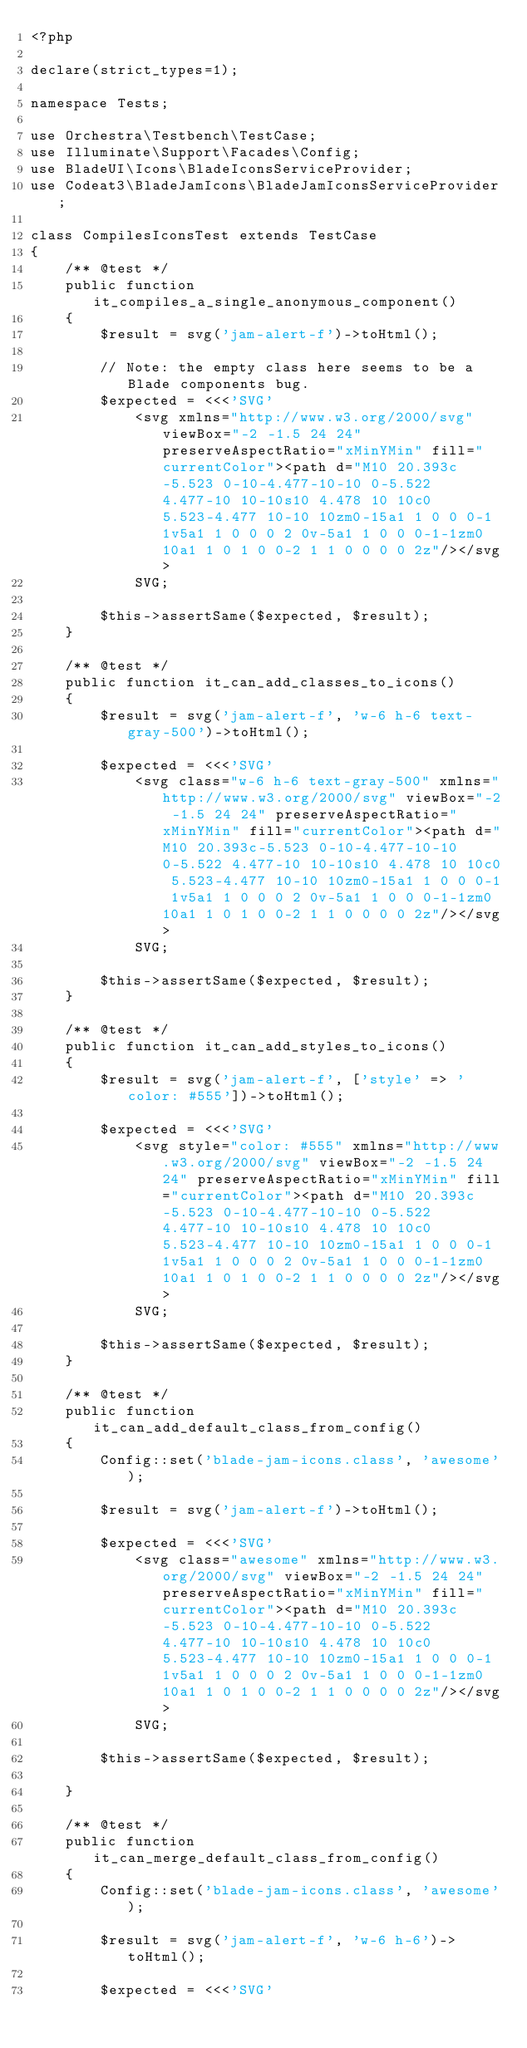<code> <loc_0><loc_0><loc_500><loc_500><_PHP_><?php

declare(strict_types=1);

namespace Tests;

use Orchestra\Testbench\TestCase;
use Illuminate\Support\Facades\Config;
use BladeUI\Icons\BladeIconsServiceProvider;
use Codeat3\BladeJamIcons\BladeJamIconsServiceProvider;

class CompilesIconsTest extends TestCase
{
    /** @test */
    public function it_compiles_a_single_anonymous_component()
    {
        $result = svg('jam-alert-f')->toHtml();

        // Note: the empty class here seems to be a Blade components bug.
        $expected = <<<'SVG'
            <svg xmlns="http://www.w3.org/2000/svg" viewBox="-2 -1.5 24 24" preserveAspectRatio="xMinYMin" fill="currentColor"><path d="M10 20.393c-5.523 0-10-4.477-10-10 0-5.522 4.477-10 10-10s10 4.478 10 10c0 5.523-4.477 10-10 10zm0-15a1 1 0 0 0-1 1v5a1 1 0 0 0 2 0v-5a1 1 0 0 0-1-1zm0 10a1 1 0 1 0 0-2 1 1 0 0 0 0 2z"/></svg>
            SVG;

        $this->assertSame($expected, $result);
    }

    /** @test */
    public function it_can_add_classes_to_icons()
    {
        $result = svg('jam-alert-f', 'w-6 h-6 text-gray-500')->toHtml();

        $expected = <<<'SVG'
            <svg class="w-6 h-6 text-gray-500" xmlns="http://www.w3.org/2000/svg" viewBox="-2 -1.5 24 24" preserveAspectRatio="xMinYMin" fill="currentColor"><path d="M10 20.393c-5.523 0-10-4.477-10-10 0-5.522 4.477-10 10-10s10 4.478 10 10c0 5.523-4.477 10-10 10zm0-15a1 1 0 0 0-1 1v5a1 1 0 0 0 2 0v-5a1 1 0 0 0-1-1zm0 10a1 1 0 1 0 0-2 1 1 0 0 0 0 2z"/></svg>
            SVG;

        $this->assertSame($expected, $result);
    }

    /** @test */
    public function it_can_add_styles_to_icons()
    {
        $result = svg('jam-alert-f', ['style' => 'color: #555'])->toHtml();

        $expected = <<<'SVG'
            <svg style="color: #555" xmlns="http://www.w3.org/2000/svg" viewBox="-2 -1.5 24 24" preserveAspectRatio="xMinYMin" fill="currentColor"><path d="M10 20.393c-5.523 0-10-4.477-10-10 0-5.522 4.477-10 10-10s10 4.478 10 10c0 5.523-4.477 10-10 10zm0-15a1 1 0 0 0-1 1v5a1 1 0 0 0 2 0v-5a1 1 0 0 0-1-1zm0 10a1 1 0 1 0 0-2 1 1 0 0 0 0 2z"/></svg>
            SVG;

        $this->assertSame($expected, $result);
    }

    /** @test */
    public function it_can_add_default_class_from_config()
    {
        Config::set('blade-jam-icons.class', 'awesome');

        $result = svg('jam-alert-f')->toHtml();

        $expected = <<<'SVG'
            <svg class="awesome" xmlns="http://www.w3.org/2000/svg" viewBox="-2 -1.5 24 24" preserveAspectRatio="xMinYMin" fill="currentColor"><path d="M10 20.393c-5.523 0-10-4.477-10-10 0-5.522 4.477-10 10-10s10 4.478 10 10c0 5.523-4.477 10-10 10zm0-15a1 1 0 0 0-1 1v5a1 1 0 0 0 2 0v-5a1 1 0 0 0-1-1zm0 10a1 1 0 1 0 0-2 1 1 0 0 0 0 2z"/></svg>
            SVG;

        $this->assertSame($expected, $result);

    }

    /** @test */
    public function it_can_merge_default_class_from_config()
    {
        Config::set('blade-jam-icons.class', 'awesome');

        $result = svg('jam-alert-f', 'w-6 h-6')->toHtml();

        $expected = <<<'SVG'</code> 